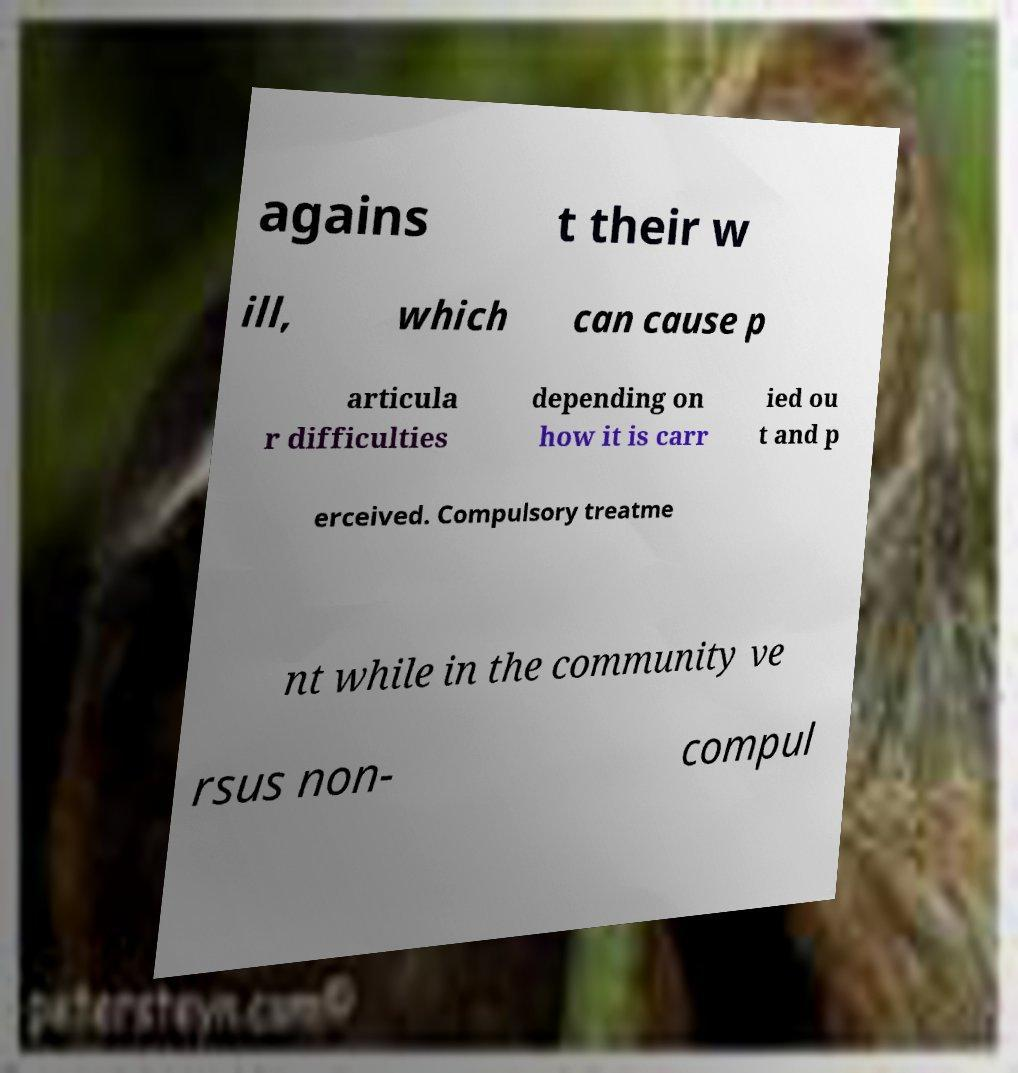Can you accurately transcribe the text from the provided image for me? agains t their w ill, which can cause p articula r difficulties depending on how it is carr ied ou t and p erceived. Compulsory treatme nt while in the community ve rsus non- compul 